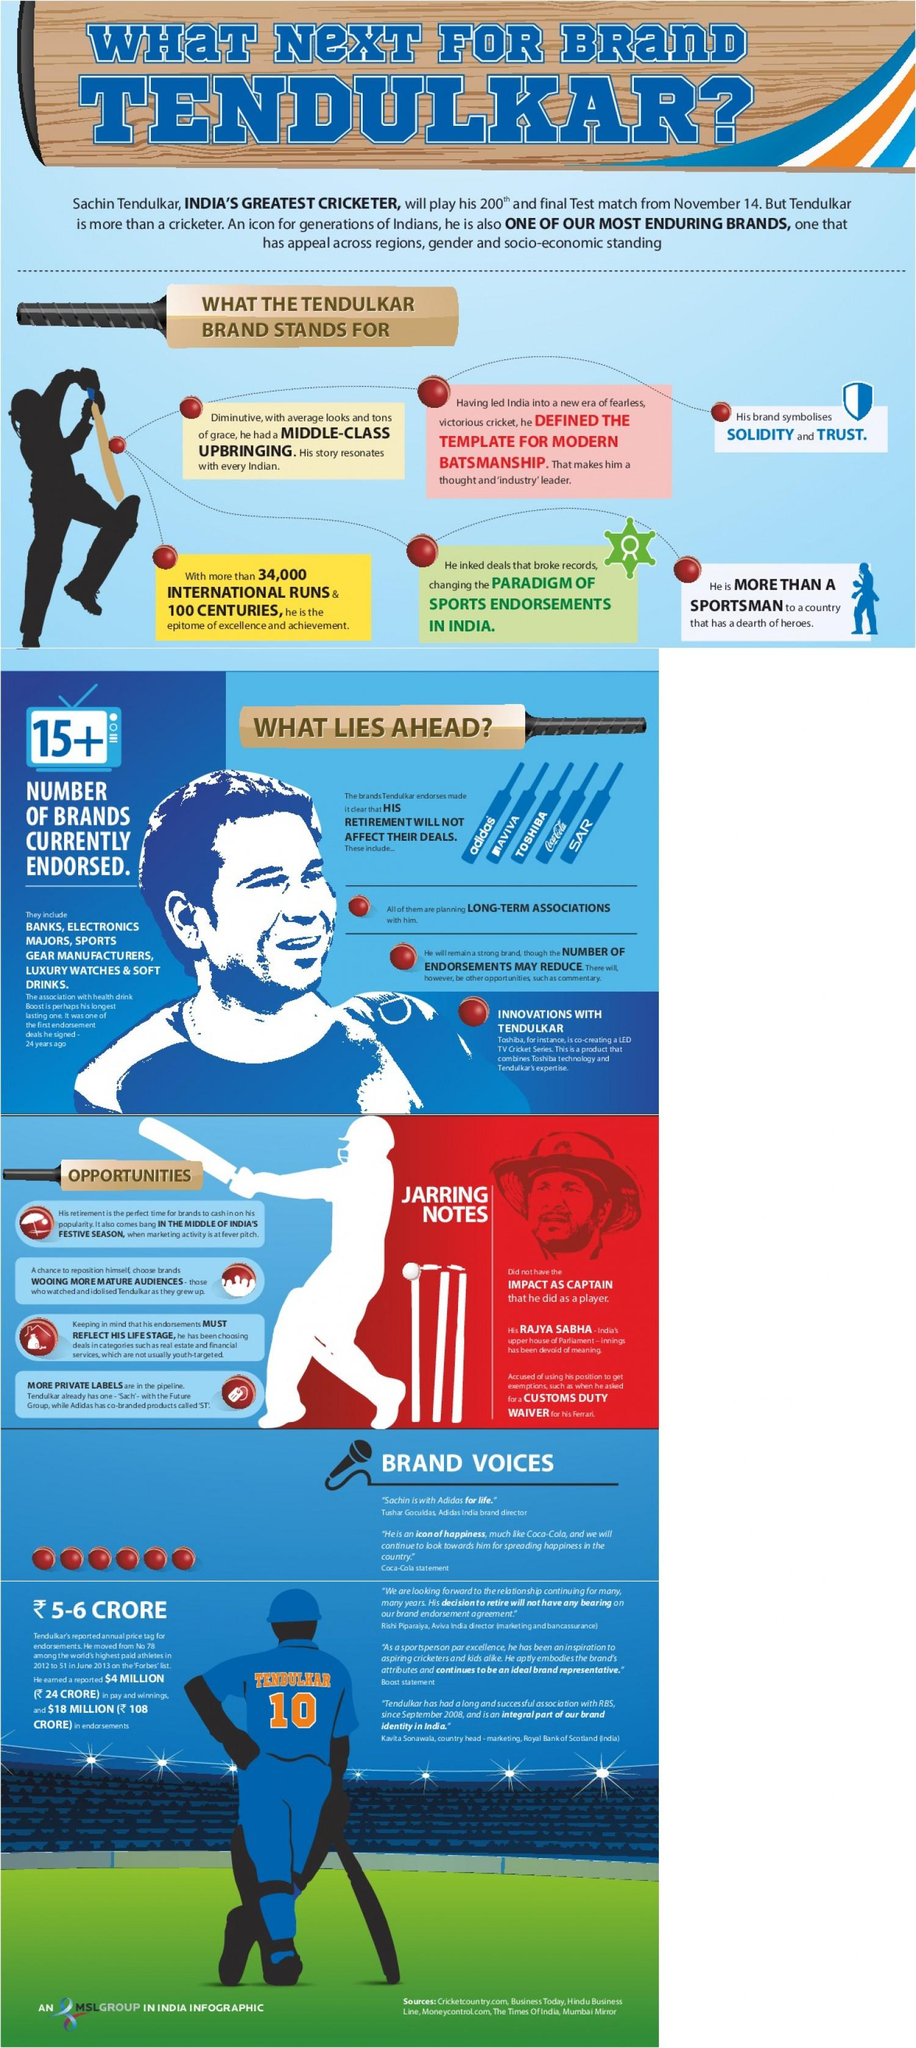List a handful of essential elements in this visual. The infographic contains five brand names. 